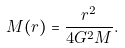<formula> <loc_0><loc_0><loc_500><loc_500>M ( r ) = \frac { r ^ { 2 } } { 4 G ^ { 2 } M } .</formula> 